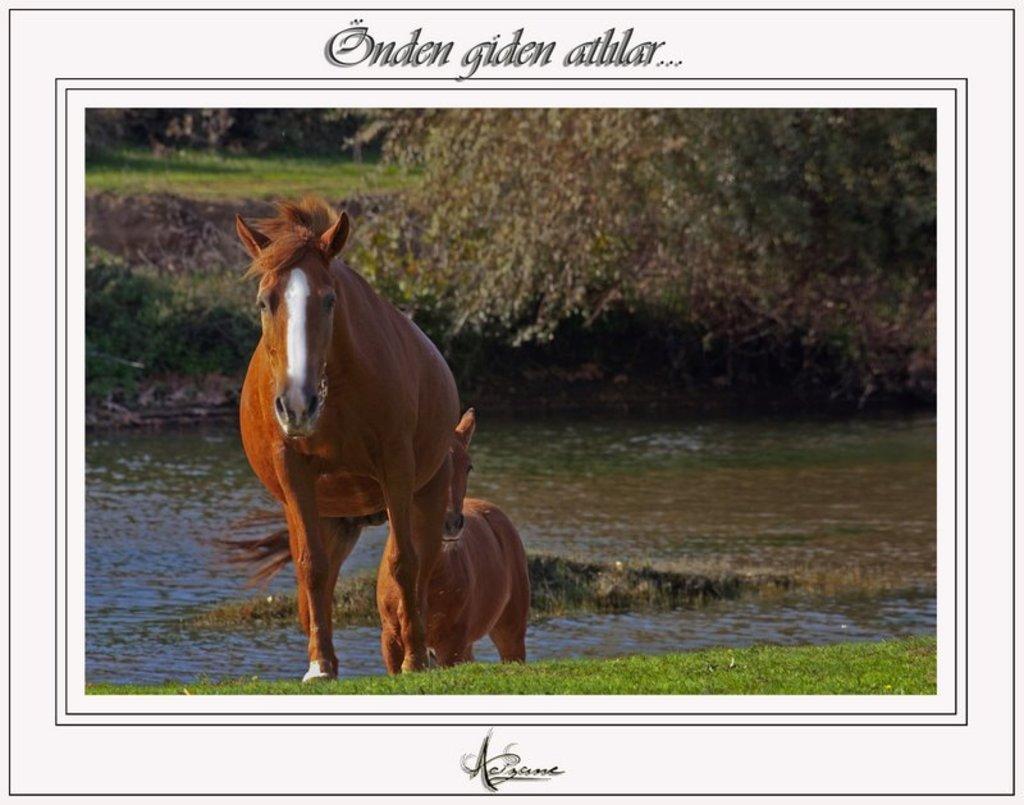Describe this image in one or two sentences. In this picture we can see poster, in this poster we can see horses, water, grass and trees. At the top and bottom of the image we can see text. 